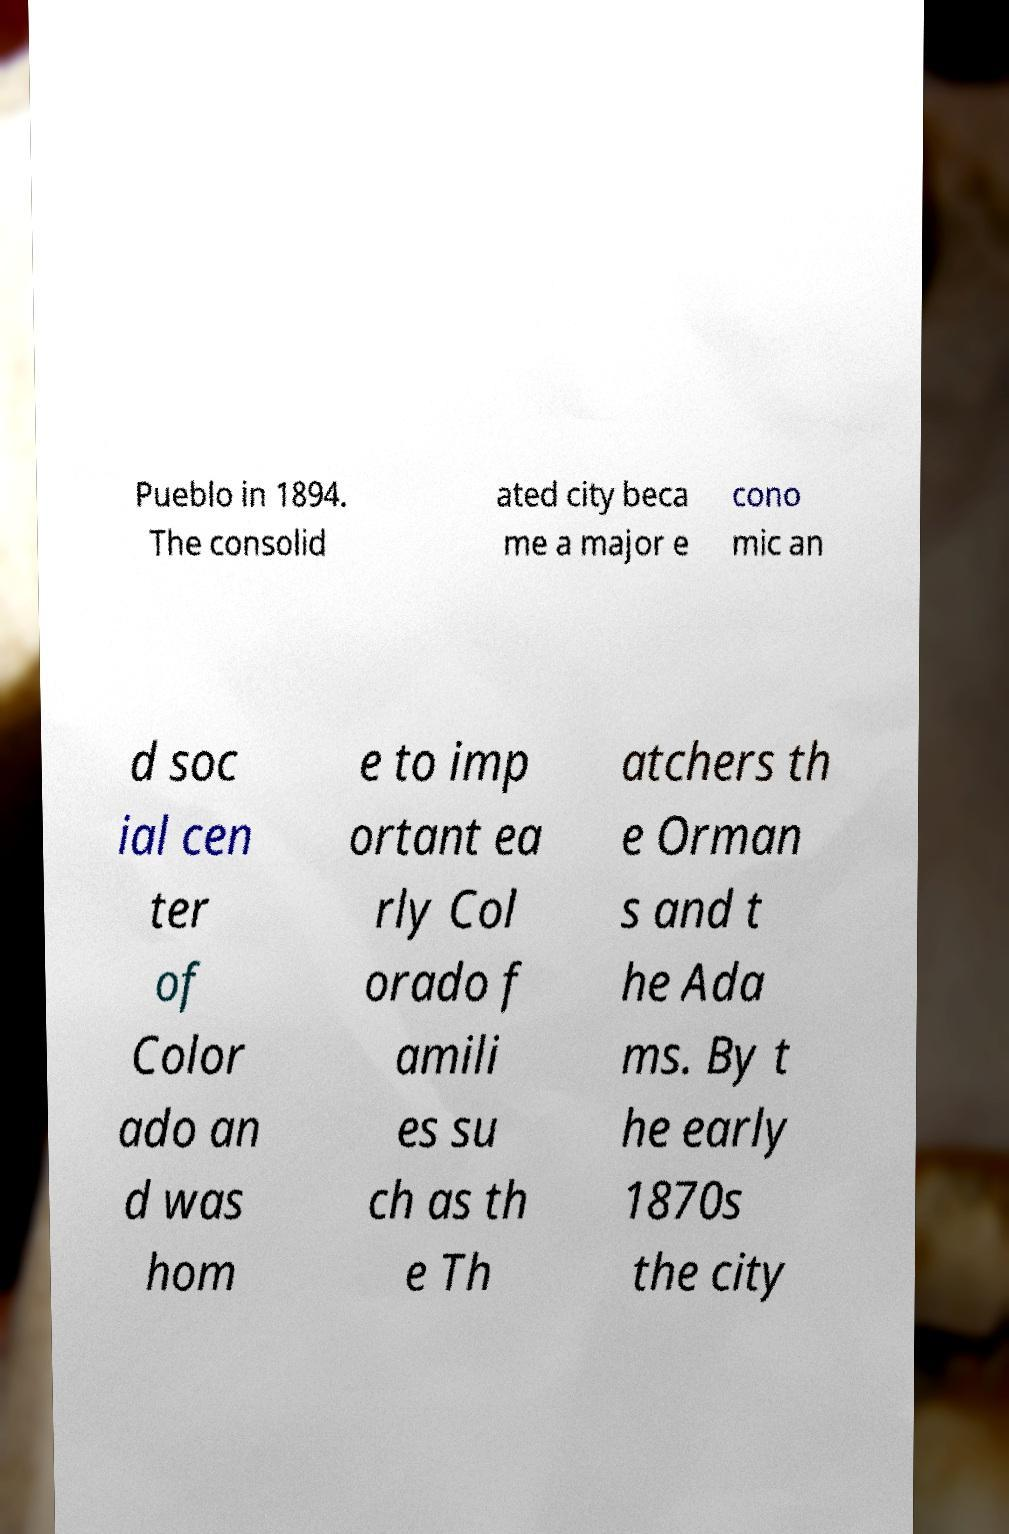Please identify and transcribe the text found in this image. Pueblo in 1894. The consolid ated city beca me a major e cono mic an d soc ial cen ter of Color ado an d was hom e to imp ortant ea rly Col orado f amili es su ch as th e Th atchers th e Orman s and t he Ada ms. By t he early 1870s the city 